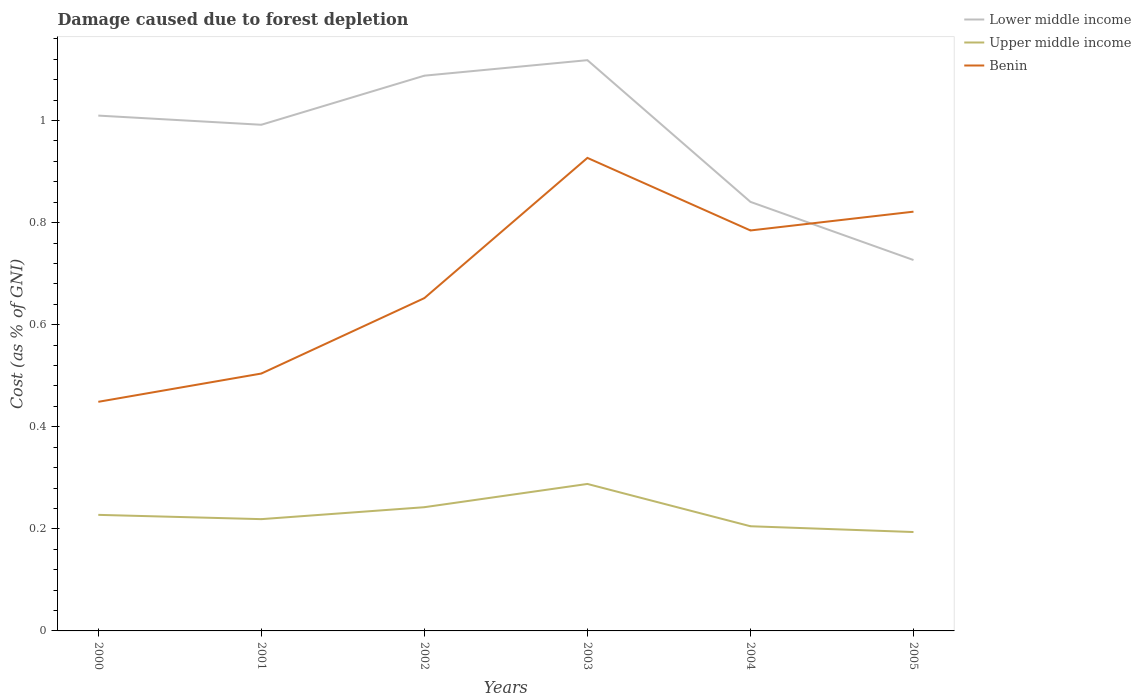How many different coloured lines are there?
Offer a terse response. 3. Does the line corresponding to Benin intersect with the line corresponding to Upper middle income?
Provide a succinct answer. No. Is the number of lines equal to the number of legend labels?
Your answer should be very brief. Yes. Across all years, what is the maximum cost of damage caused due to forest depletion in Lower middle income?
Your answer should be compact. 0.73. In which year was the cost of damage caused due to forest depletion in Upper middle income maximum?
Provide a short and direct response. 2005. What is the total cost of damage caused due to forest depletion in Lower middle income in the graph?
Your answer should be compact. -0.03. What is the difference between the highest and the second highest cost of damage caused due to forest depletion in Upper middle income?
Offer a very short reply. 0.09. What is the difference between the highest and the lowest cost of damage caused due to forest depletion in Benin?
Give a very brief answer. 3. What is the difference between two consecutive major ticks on the Y-axis?
Offer a very short reply. 0.2. How many legend labels are there?
Keep it short and to the point. 3. What is the title of the graph?
Ensure brevity in your answer.  Damage caused due to forest depletion. Does "Botswana" appear as one of the legend labels in the graph?
Offer a terse response. No. What is the label or title of the X-axis?
Offer a terse response. Years. What is the label or title of the Y-axis?
Give a very brief answer. Cost (as % of GNI). What is the Cost (as % of GNI) of Lower middle income in 2000?
Your answer should be compact. 1.01. What is the Cost (as % of GNI) in Upper middle income in 2000?
Your answer should be very brief. 0.23. What is the Cost (as % of GNI) in Benin in 2000?
Offer a very short reply. 0.45. What is the Cost (as % of GNI) of Lower middle income in 2001?
Your answer should be compact. 0.99. What is the Cost (as % of GNI) of Upper middle income in 2001?
Ensure brevity in your answer.  0.22. What is the Cost (as % of GNI) in Benin in 2001?
Provide a short and direct response. 0.5. What is the Cost (as % of GNI) in Lower middle income in 2002?
Provide a succinct answer. 1.09. What is the Cost (as % of GNI) in Upper middle income in 2002?
Offer a very short reply. 0.24. What is the Cost (as % of GNI) in Benin in 2002?
Your answer should be compact. 0.65. What is the Cost (as % of GNI) of Lower middle income in 2003?
Provide a succinct answer. 1.12. What is the Cost (as % of GNI) of Upper middle income in 2003?
Give a very brief answer. 0.29. What is the Cost (as % of GNI) of Benin in 2003?
Provide a short and direct response. 0.93. What is the Cost (as % of GNI) in Lower middle income in 2004?
Keep it short and to the point. 0.84. What is the Cost (as % of GNI) of Upper middle income in 2004?
Offer a very short reply. 0.21. What is the Cost (as % of GNI) in Benin in 2004?
Your response must be concise. 0.78. What is the Cost (as % of GNI) in Lower middle income in 2005?
Provide a short and direct response. 0.73. What is the Cost (as % of GNI) of Upper middle income in 2005?
Provide a succinct answer. 0.19. What is the Cost (as % of GNI) of Benin in 2005?
Offer a very short reply. 0.82. Across all years, what is the maximum Cost (as % of GNI) of Lower middle income?
Provide a succinct answer. 1.12. Across all years, what is the maximum Cost (as % of GNI) in Upper middle income?
Make the answer very short. 0.29. Across all years, what is the maximum Cost (as % of GNI) in Benin?
Your answer should be very brief. 0.93. Across all years, what is the minimum Cost (as % of GNI) in Lower middle income?
Keep it short and to the point. 0.73. Across all years, what is the minimum Cost (as % of GNI) of Upper middle income?
Keep it short and to the point. 0.19. Across all years, what is the minimum Cost (as % of GNI) in Benin?
Make the answer very short. 0.45. What is the total Cost (as % of GNI) of Lower middle income in the graph?
Provide a succinct answer. 5.78. What is the total Cost (as % of GNI) of Upper middle income in the graph?
Provide a succinct answer. 1.38. What is the total Cost (as % of GNI) of Benin in the graph?
Offer a very short reply. 4.14. What is the difference between the Cost (as % of GNI) in Lower middle income in 2000 and that in 2001?
Your response must be concise. 0.02. What is the difference between the Cost (as % of GNI) of Upper middle income in 2000 and that in 2001?
Ensure brevity in your answer.  0.01. What is the difference between the Cost (as % of GNI) in Benin in 2000 and that in 2001?
Your answer should be compact. -0.06. What is the difference between the Cost (as % of GNI) of Lower middle income in 2000 and that in 2002?
Provide a succinct answer. -0.08. What is the difference between the Cost (as % of GNI) in Upper middle income in 2000 and that in 2002?
Your answer should be very brief. -0.01. What is the difference between the Cost (as % of GNI) of Benin in 2000 and that in 2002?
Ensure brevity in your answer.  -0.2. What is the difference between the Cost (as % of GNI) of Lower middle income in 2000 and that in 2003?
Your answer should be very brief. -0.11. What is the difference between the Cost (as % of GNI) in Upper middle income in 2000 and that in 2003?
Make the answer very short. -0.06. What is the difference between the Cost (as % of GNI) of Benin in 2000 and that in 2003?
Provide a succinct answer. -0.48. What is the difference between the Cost (as % of GNI) in Lower middle income in 2000 and that in 2004?
Provide a succinct answer. 0.17. What is the difference between the Cost (as % of GNI) of Upper middle income in 2000 and that in 2004?
Make the answer very short. 0.02. What is the difference between the Cost (as % of GNI) in Benin in 2000 and that in 2004?
Make the answer very short. -0.34. What is the difference between the Cost (as % of GNI) of Lower middle income in 2000 and that in 2005?
Provide a succinct answer. 0.28. What is the difference between the Cost (as % of GNI) of Upper middle income in 2000 and that in 2005?
Your answer should be very brief. 0.03. What is the difference between the Cost (as % of GNI) of Benin in 2000 and that in 2005?
Offer a terse response. -0.37. What is the difference between the Cost (as % of GNI) of Lower middle income in 2001 and that in 2002?
Your answer should be compact. -0.1. What is the difference between the Cost (as % of GNI) in Upper middle income in 2001 and that in 2002?
Provide a succinct answer. -0.02. What is the difference between the Cost (as % of GNI) of Benin in 2001 and that in 2002?
Provide a short and direct response. -0.15. What is the difference between the Cost (as % of GNI) in Lower middle income in 2001 and that in 2003?
Ensure brevity in your answer.  -0.13. What is the difference between the Cost (as % of GNI) in Upper middle income in 2001 and that in 2003?
Ensure brevity in your answer.  -0.07. What is the difference between the Cost (as % of GNI) of Benin in 2001 and that in 2003?
Your response must be concise. -0.42. What is the difference between the Cost (as % of GNI) of Lower middle income in 2001 and that in 2004?
Your answer should be compact. 0.15. What is the difference between the Cost (as % of GNI) of Upper middle income in 2001 and that in 2004?
Your answer should be very brief. 0.01. What is the difference between the Cost (as % of GNI) of Benin in 2001 and that in 2004?
Make the answer very short. -0.28. What is the difference between the Cost (as % of GNI) in Lower middle income in 2001 and that in 2005?
Ensure brevity in your answer.  0.27. What is the difference between the Cost (as % of GNI) of Upper middle income in 2001 and that in 2005?
Provide a short and direct response. 0.03. What is the difference between the Cost (as % of GNI) of Benin in 2001 and that in 2005?
Your answer should be very brief. -0.32. What is the difference between the Cost (as % of GNI) in Lower middle income in 2002 and that in 2003?
Provide a short and direct response. -0.03. What is the difference between the Cost (as % of GNI) of Upper middle income in 2002 and that in 2003?
Your answer should be very brief. -0.05. What is the difference between the Cost (as % of GNI) of Benin in 2002 and that in 2003?
Your answer should be very brief. -0.27. What is the difference between the Cost (as % of GNI) in Lower middle income in 2002 and that in 2004?
Offer a very short reply. 0.25. What is the difference between the Cost (as % of GNI) in Upper middle income in 2002 and that in 2004?
Your answer should be compact. 0.04. What is the difference between the Cost (as % of GNI) in Benin in 2002 and that in 2004?
Your answer should be very brief. -0.13. What is the difference between the Cost (as % of GNI) of Lower middle income in 2002 and that in 2005?
Give a very brief answer. 0.36. What is the difference between the Cost (as % of GNI) in Upper middle income in 2002 and that in 2005?
Keep it short and to the point. 0.05. What is the difference between the Cost (as % of GNI) in Benin in 2002 and that in 2005?
Provide a succinct answer. -0.17. What is the difference between the Cost (as % of GNI) of Lower middle income in 2003 and that in 2004?
Your answer should be very brief. 0.28. What is the difference between the Cost (as % of GNI) in Upper middle income in 2003 and that in 2004?
Your answer should be compact. 0.08. What is the difference between the Cost (as % of GNI) in Benin in 2003 and that in 2004?
Provide a short and direct response. 0.14. What is the difference between the Cost (as % of GNI) in Lower middle income in 2003 and that in 2005?
Your answer should be very brief. 0.39. What is the difference between the Cost (as % of GNI) of Upper middle income in 2003 and that in 2005?
Give a very brief answer. 0.09. What is the difference between the Cost (as % of GNI) of Benin in 2003 and that in 2005?
Offer a terse response. 0.11. What is the difference between the Cost (as % of GNI) in Lower middle income in 2004 and that in 2005?
Ensure brevity in your answer.  0.11. What is the difference between the Cost (as % of GNI) of Upper middle income in 2004 and that in 2005?
Ensure brevity in your answer.  0.01. What is the difference between the Cost (as % of GNI) of Benin in 2004 and that in 2005?
Keep it short and to the point. -0.04. What is the difference between the Cost (as % of GNI) of Lower middle income in 2000 and the Cost (as % of GNI) of Upper middle income in 2001?
Your response must be concise. 0.79. What is the difference between the Cost (as % of GNI) in Lower middle income in 2000 and the Cost (as % of GNI) in Benin in 2001?
Ensure brevity in your answer.  0.51. What is the difference between the Cost (as % of GNI) in Upper middle income in 2000 and the Cost (as % of GNI) in Benin in 2001?
Make the answer very short. -0.28. What is the difference between the Cost (as % of GNI) of Lower middle income in 2000 and the Cost (as % of GNI) of Upper middle income in 2002?
Give a very brief answer. 0.77. What is the difference between the Cost (as % of GNI) in Lower middle income in 2000 and the Cost (as % of GNI) in Benin in 2002?
Make the answer very short. 0.36. What is the difference between the Cost (as % of GNI) of Upper middle income in 2000 and the Cost (as % of GNI) of Benin in 2002?
Provide a succinct answer. -0.42. What is the difference between the Cost (as % of GNI) of Lower middle income in 2000 and the Cost (as % of GNI) of Upper middle income in 2003?
Provide a short and direct response. 0.72. What is the difference between the Cost (as % of GNI) in Lower middle income in 2000 and the Cost (as % of GNI) in Benin in 2003?
Your answer should be compact. 0.08. What is the difference between the Cost (as % of GNI) of Upper middle income in 2000 and the Cost (as % of GNI) of Benin in 2003?
Offer a terse response. -0.7. What is the difference between the Cost (as % of GNI) in Lower middle income in 2000 and the Cost (as % of GNI) in Upper middle income in 2004?
Make the answer very short. 0.8. What is the difference between the Cost (as % of GNI) of Lower middle income in 2000 and the Cost (as % of GNI) of Benin in 2004?
Offer a terse response. 0.23. What is the difference between the Cost (as % of GNI) in Upper middle income in 2000 and the Cost (as % of GNI) in Benin in 2004?
Provide a succinct answer. -0.56. What is the difference between the Cost (as % of GNI) in Lower middle income in 2000 and the Cost (as % of GNI) in Upper middle income in 2005?
Provide a succinct answer. 0.82. What is the difference between the Cost (as % of GNI) of Lower middle income in 2000 and the Cost (as % of GNI) of Benin in 2005?
Offer a very short reply. 0.19. What is the difference between the Cost (as % of GNI) of Upper middle income in 2000 and the Cost (as % of GNI) of Benin in 2005?
Offer a terse response. -0.59. What is the difference between the Cost (as % of GNI) of Lower middle income in 2001 and the Cost (as % of GNI) of Upper middle income in 2002?
Give a very brief answer. 0.75. What is the difference between the Cost (as % of GNI) of Lower middle income in 2001 and the Cost (as % of GNI) of Benin in 2002?
Ensure brevity in your answer.  0.34. What is the difference between the Cost (as % of GNI) in Upper middle income in 2001 and the Cost (as % of GNI) in Benin in 2002?
Your response must be concise. -0.43. What is the difference between the Cost (as % of GNI) of Lower middle income in 2001 and the Cost (as % of GNI) of Upper middle income in 2003?
Your answer should be compact. 0.7. What is the difference between the Cost (as % of GNI) of Lower middle income in 2001 and the Cost (as % of GNI) of Benin in 2003?
Ensure brevity in your answer.  0.06. What is the difference between the Cost (as % of GNI) of Upper middle income in 2001 and the Cost (as % of GNI) of Benin in 2003?
Your answer should be compact. -0.71. What is the difference between the Cost (as % of GNI) in Lower middle income in 2001 and the Cost (as % of GNI) in Upper middle income in 2004?
Your answer should be very brief. 0.79. What is the difference between the Cost (as % of GNI) in Lower middle income in 2001 and the Cost (as % of GNI) in Benin in 2004?
Provide a succinct answer. 0.21. What is the difference between the Cost (as % of GNI) in Upper middle income in 2001 and the Cost (as % of GNI) in Benin in 2004?
Your response must be concise. -0.57. What is the difference between the Cost (as % of GNI) of Lower middle income in 2001 and the Cost (as % of GNI) of Upper middle income in 2005?
Ensure brevity in your answer.  0.8. What is the difference between the Cost (as % of GNI) in Lower middle income in 2001 and the Cost (as % of GNI) in Benin in 2005?
Ensure brevity in your answer.  0.17. What is the difference between the Cost (as % of GNI) of Upper middle income in 2001 and the Cost (as % of GNI) of Benin in 2005?
Ensure brevity in your answer.  -0.6. What is the difference between the Cost (as % of GNI) in Lower middle income in 2002 and the Cost (as % of GNI) in Benin in 2003?
Offer a very short reply. 0.16. What is the difference between the Cost (as % of GNI) of Upper middle income in 2002 and the Cost (as % of GNI) of Benin in 2003?
Give a very brief answer. -0.68. What is the difference between the Cost (as % of GNI) in Lower middle income in 2002 and the Cost (as % of GNI) in Upper middle income in 2004?
Ensure brevity in your answer.  0.88. What is the difference between the Cost (as % of GNI) of Lower middle income in 2002 and the Cost (as % of GNI) of Benin in 2004?
Your answer should be very brief. 0.3. What is the difference between the Cost (as % of GNI) in Upper middle income in 2002 and the Cost (as % of GNI) in Benin in 2004?
Your answer should be compact. -0.54. What is the difference between the Cost (as % of GNI) in Lower middle income in 2002 and the Cost (as % of GNI) in Upper middle income in 2005?
Your answer should be very brief. 0.89. What is the difference between the Cost (as % of GNI) in Lower middle income in 2002 and the Cost (as % of GNI) in Benin in 2005?
Ensure brevity in your answer.  0.27. What is the difference between the Cost (as % of GNI) of Upper middle income in 2002 and the Cost (as % of GNI) of Benin in 2005?
Make the answer very short. -0.58. What is the difference between the Cost (as % of GNI) in Lower middle income in 2003 and the Cost (as % of GNI) in Upper middle income in 2004?
Your answer should be compact. 0.91. What is the difference between the Cost (as % of GNI) of Lower middle income in 2003 and the Cost (as % of GNI) of Benin in 2004?
Offer a very short reply. 0.33. What is the difference between the Cost (as % of GNI) of Upper middle income in 2003 and the Cost (as % of GNI) of Benin in 2004?
Your answer should be very brief. -0.5. What is the difference between the Cost (as % of GNI) in Lower middle income in 2003 and the Cost (as % of GNI) in Upper middle income in 2005?
Provide a succinct answer. 0.92. What is the difference between the Cost (as % of GNI) in Lower middle income in 2003 and the Cost (as % of GNI) in Benin in 2005?
Give a very brief answer. 0.3. What is the difference between the Cost (as % of GNI) of Upper middle income in 2003 and the Cost (as % of GNI) of Benin in 2005?
Ensure brevity in your answer.  -0.53. What is the difference between the Cost (as % of GNI) in Lower middle income in 2004 and the Cost (as % of GNI) in Upper middle income in 2005?
Make the answer very short. 0.65. What is the difference between the Cost (as % of GNI) in Lower middle income in 2004 and the Cost (as % of GNI) in Benin in 2005?
Make the answer very short. 0.02. What is the difference between the Cost (as % of GNI) in Upper middle income in 2004 and the Cost (as % of GNI) in Benin in 2005?
Provide a succinct answer. -0.62. What is the average Cost (as % of GNI) in Lower middle income per year?
Keep it short and to the point. 0.96. What is the average Cost (as % of GNI) in Upper middle income per year?
Provide a succinct answer. 0.23. What is the average Cost (as % of GNI) of Benin per year?
Offer a very short reply. 0.69. In the year 2000, what is the difference between the Cost (as % of GNI) in Lower middle income and Cost (as % of GNI) in Upper middle income?
Provide a succinct answer. 0.78. In the year 2000, what is the difference between the Cost (as % of GNI) of Lower middle income and Cost (as % of GNI) of Benin?
Offer a terse response. 0.56. In the year 2000, what is the difference between the Cost (as % of GNI) of Upper middle income and Cost (as % of GNI) of Benin?
Provide a succinct answer. -0.22. In the year 2001, what is the difference between the Cost (as % of GNI) of Lower middle income and Cost (as % of GNI) of Upper middle income?
Your answer should be compact. 0.77. In the year 2001, what is the difference between the Cost (as % of GNI) of Lower middle income and Cost (as % of GNI) of Benin?
Make the answer very short. 0.49. In the year 2001, what is the difference between the Cost (as % of GNI) of Upper middle income and Cost (as % of GNI) of Benin?
Make the answer very short. -0.29. In the year 2002, what is the difference between the Cost (as % of GNI) in Lower middle income and Cost (as % of GNI) in Upper middle income?
Keep it short and to the point. 0.85. In the year 2002, what is the difference between the Cost (as % of GNI) in Lower middle income and Cost (as % of GNI) in Benin?
Your response must be concise. 0.44. In the year 2002, what is the difference between the Cost (as % of GNI) of Upper middle income and Cost (as % of GNI) of Benin?
Offer a very short reply. -0.41. In the year 2003, what is the difference between the Cost (as % of GNI) of Lower middle income and Cost (as % of GNI) of Upper middle income?
Provide a short and direct response. 0.83. In the year 2003, what is the difference between the Cost (as % of GNI) of Lower middle income and Cost (as % of GNI) of Benin?
Make the answer very short. 0.19. In the year 2003, what is the difference between the Cost (as % of GNI) in Upper middle income and Cost (as % of GNI) in Benin?
Give a very brief answer. -0.64. In the year 2004, what is the difference between the Cost (as % of GNI) in Lower middle income and Cost (as % of GNI) in Upper middle income?
Keep it short and to the point. 0.64. In the year 2004, what is the difference between the Cost (as % of GNI) of Lower middle income and Cost (as % of GNI) of Benin?
Give a very brief answer. 0.06. In the year 2004, what is the difference between the Cost (as % of GNI) in Upper middle income and Cost (as % of GNI) in Benin?
Provide a short and direct response. -0.58. In the year 2005, what is the difference between the Cost (as % of GNI) of Lower middle income and Cost (as % of GNI) of Upper middle income?
Make the answer very short. 0.53. In the year 2005, what is the difference between the Cost (as % of GNI) of Lower middle income and Cost (as % of GNI) of Benin?
Ensure brevity in your answer.  -0.09. In the year 2005, what is the difference between the Cost (as % of GNI) in Upper middle income and Cost (as % of GNI) in Benin?
Ensure brevity in your answer.  -0.63. What is the ratio of the Cost (as % of GNI) of Lower middle income in 2000 to that in 2001?
Your answer should be very brief. 1.02. What is the ratio of the Cost (as % of GNI) in Upper middle income in 2000 to that in 2001?
Offer a very short reply. 1.04. What is the ratio of the Cost (as % of GNI) in Benin in 2000 to that in 2001?
Offer a very short reply. 0.89. What is the ratio of the Cost (as % of GNI) in Lower middle income in 2000 to that in 2002?
Make the answer very short. 0.93. What is the ratio of the Cost (as % of GNI) in Upper middle income in 2000 to that in 2002?
Provide a succinct answer. 0.94. What is the ratio of the Cost (as % of GNI) in Benin in 2000 to that in 2002?
Offer a terse response. 0.69. What is the ratio of the Cost (as % of GNI) of Lower middle income in 2000 to that in 2003?
Keep it short and to the point. 0.9. What is the ratio of the Cost (as % of GNI) in Upper middle income in 2000 to that in 2003?
Provide a succinct answer. 0.79. What is the ratio of the Cost (as % of GNI) in Benin in 2000 to that in 2003?
Ensure brevity in your answer.  0.48. What is the ratio of the Cost (as % of GNI) of Lower middle income in 2000 to that in 2004?
Give a very brief answer. 1.2. What is the ratio of the Cost (as % of GNI) of Upper middle income in 2000 to that in 2004?
Offer a very short reply. 1.11. What is the ratio of the Cost (as % of GNI) of Benin in 2000 to that in 2004?
Give a very brief answer. 0.57. What is the ratio of the Cost (as % of GNI) in Lower middle income in 2000 to that in 2005?
Make the answer very short. 1.39. What is the ratio of the Cost (as % of GNI) in Upper middle income in 2000 to that in 2005?
Provide a short and direct response. 1.17. What is the ratio of the Cost (as % of GNI) of Benin in 2000 to that in 2005?
Keep it short and to the point. 0.55. What is the ratio of the Cost (as % of GNI) of Lower middle income in 2001 to that in 2002?
Ensure brevity in your answer.  0.91. What is the ratio of the Cost (as % of GNI) of Upper middle income in 2001 to that in 2002?
Offer a very short reply. 0.9. What is the ratio of the Cost (as % of GNI) of Benin in 2001 to that in 2002?
Keep it short and to the point. 0.77. What is the ratio of the Cost (as % of GNI) of Lower middle income in 2001 to that in 2003?
Give a very brief answer. 0.89. What is the ratio of the Cost (as % of GNI) in Upper middle income in 2001 to that in 2003?
Provide a short and direct response. 0.76. What is the ratio of the Cost (as % of GNI) of Benin in 2001 to that in 2003?
Your answer should be compact. 0.54. What is the ratio of the Cost (as % of GNI) in Lower middle income in 2001 to that in 2004?
Ensure brevity in your answer.  1.18. What is the ratio of the Cost (as % of GNI) in Upper middle income in 2001 to that in 2004?
Provide a succinct answer. 1.07. What is the ratio of the Cost (as % of GNI) of Benin in 2001 to that in 2004?
Your answer should be compact. 0.64. What is the ratio of the Cost (as % of GNI) of Lower middle income in 2001 to that in 2005?
Offer a terse response. 1.36. What is the ratio of the Cost (as % of GNI) in Upper middle income in 2001 to that in 2005?
Your response must be concise. 1.13. What is the ratio of the Cost (as % of GNI) in Benin in 2001 to that in 2005?
Your answer should be compact. 0.61. What is the ratio of the Cost (as % of GNI) of Lower middle income in 2002 to that in 2003?
Provide a short and direct response. 0.97. What is the ratio of the Cost (as % of GNI) of Upper middle income in 2002 to that in 2003?
Your response must be concise. 0.84. What is the ratio of the Cost (as % of GNI) of Benin in 2002 to that in 2003?
Provide a succinct answer. 0.7. What is the ratio of the Cost (as % of GNI) of Lower middle income in 2002 to that in 2004?
Give a very brief answer. 1.29. What is the ratio of the Cost (as % of GNI) of Upper middle income in 2002 to that in 2004?
Keep it short and to the point. 1.18. What is the ratio of the Cost (as % of GNI) of Benin in 2002 to that in 2004?
Your answer should be compact. 0.83. What is the ratio of the Cost (as % of GNI) of Lower middle income in 2002 to that in 2005?
Make the answer very short. 1.5. What is the ratio of the Cost (as % of GNI) of Upper middle income in 2002 to that in 2005?
Offer a very short reply. 1.25. What is the ratio of the Cost (as % of GNI) of Benin in 2002 to that in 2005?
Your answer should be very brief. 0.79. What is the ratio of the Cost (as % of GNI) of Lower middle income in 2003 to that in 2004?
Your answer should be very brief. 1.33. What is the ratio of the Cost (as % of GNI) in Upper middle income in 2003 to that in 2004?
Keep it short and to the point. 1.4. What is the ratio of the Cost (as % of GNI) in Benin in 2003 to that in 2004?
Your response must be concise. 1.18. What is the ratio of the Cost (as % of GNI) of Lower middle income in 2003 to that in 2005?
Keep it short and to the point. 1.54. What is the ratio of the Cost (as % of GNI) in Upper middle income in 2003 to that in 2005?
Keep it short and to the point. 1.49. What is the ratio of the Cost (as % of GNI) of Benin in 2003 to that in 2005?
Give a very brief answer. 1.13. What is the ratio of the Cost (as % of GNI) of Lower middle income in 2004 to that in 2005?
Provide a short and direct response. 1.16. What is the ratio of the Cost (as % of GNI) in Upper middle income in 2004 to that in 2005?
Offer a terse response. 1.06. What is the ratio of the Cost (as % of GNI) in Benin in 2004 to that in 2005?
Provide a succinct answer. 0.96. What is the difference between the highest and the second highest Cost (as % of GNI) in Lower middle income?
Provide a short and direct response. 0.03. What is the difference between the highest and the second highest Cost (as % of GNI) of Upper middle income?
Ensure brevity in your answer.  0.05. What is the difference between the highest and the second highest Cost (as % of GNI) of Benin?
Provide a succinct answer. 0.11. What is the difference between the highest and the lowest Cost (as % of GNI) in Lower middle income?
Make the answer very short. 0.39. What is the difference between the highest and the lowest Cost (as % of GNI) in Upper middle income?
Provide a short and direct response. 0.09. What is the difference between the highest and the lowest Cost (as % of GNI) in Benin?
Your response must be concise. 0.48. 